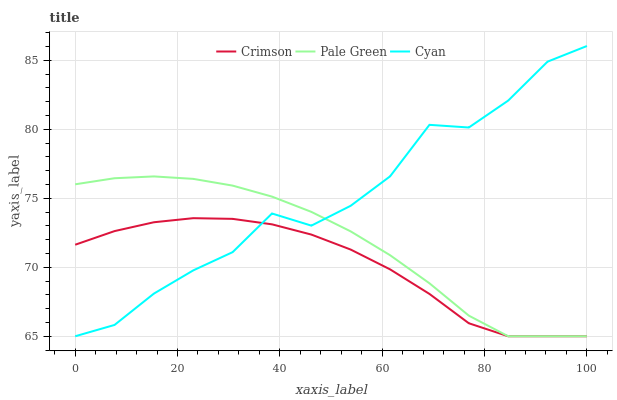Does Crimson have the minimum area under the curve?
Answer yes or no. Yes. Does Cyan have the maximum area under the curve?
Answer yes or no. Yes. Does Pale Green have the minimum area under the curve?
Answer yes or no. No. Does Pale Green have the maximum area under the curve?
Answer yes or no. No. Is Pale Green the smoothest?
Answer yes or no. Yes. Is Cyan the roughest?
Answer yes or no. Yes. Is Cyan the smoothest?
Answer yes or no. No. Is Pale Green the roughest?
Answer yes or no. No. Does Cyan have the highest value?
Answer yes or no. Yes. Does Pale Green have the highest value?
Answer yes or no. No. Does Cyan intersect Crimson?
Answer yes or no. Yes. Is Cyan less than Crimson?
Answer yes or no. No. Is Cyan greater than Crimson?
Answer yes or no. No. 